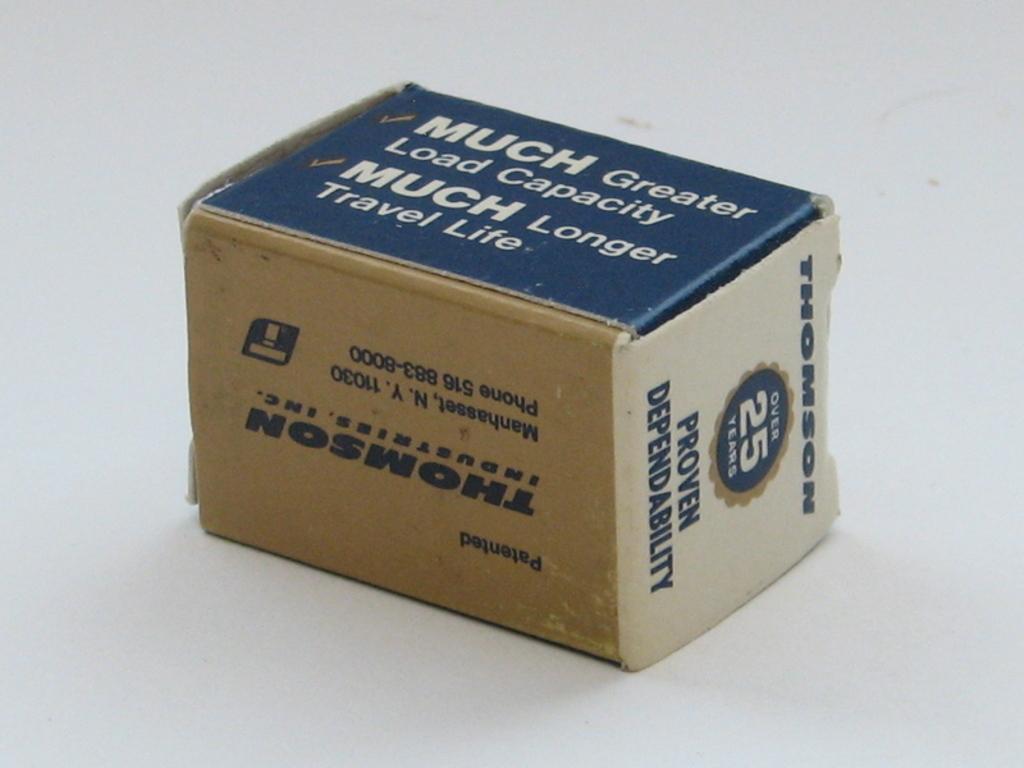What company is shown on the box?
Your answer should be compact. Thomson. What is proven about this brand?
Ensure brevity in your answer.  Dependability. 